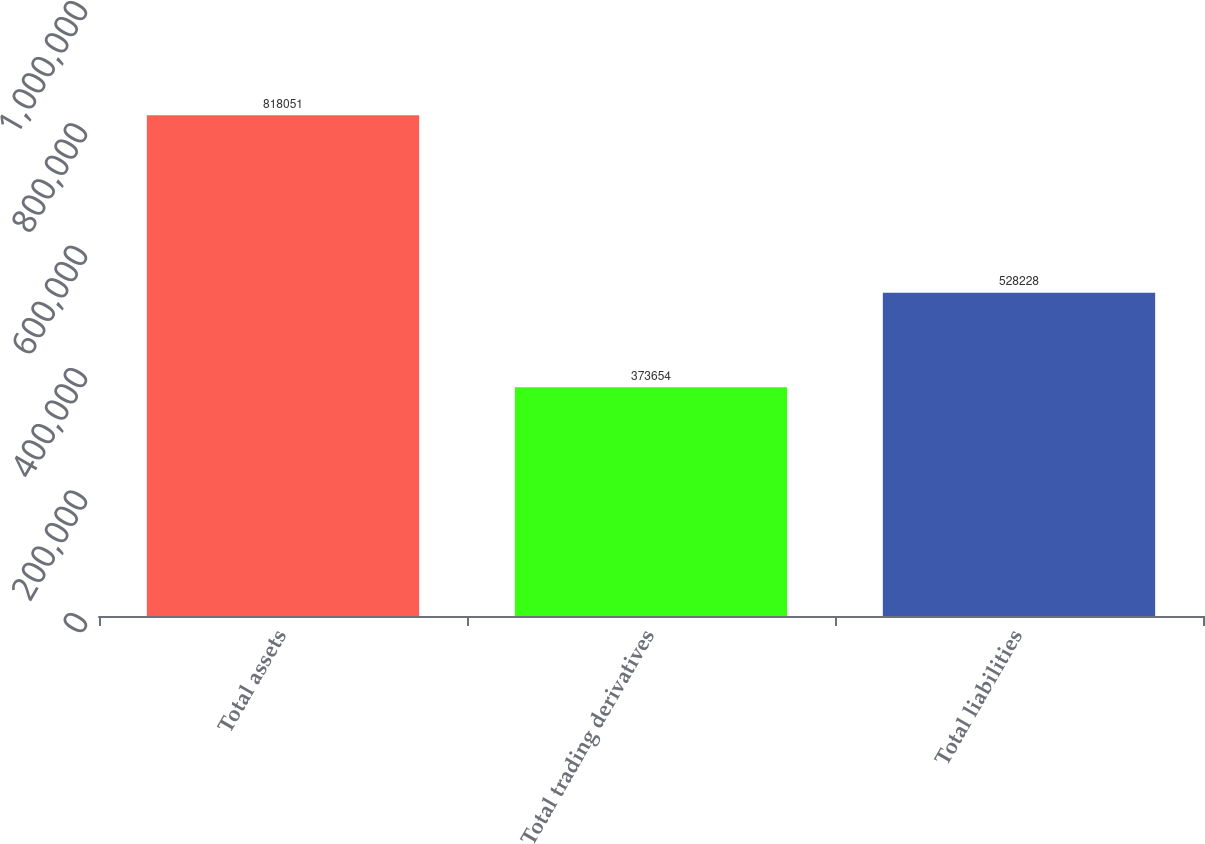<chart> <loc_0><loc_0><loc_500><loc_500><bar_chart><fcel>Total assets<fcel>Total trading derivatives<fcel>Total liabilities<nl><fcel>818051<fcel>373654<fcel>528228<nl></chart> 